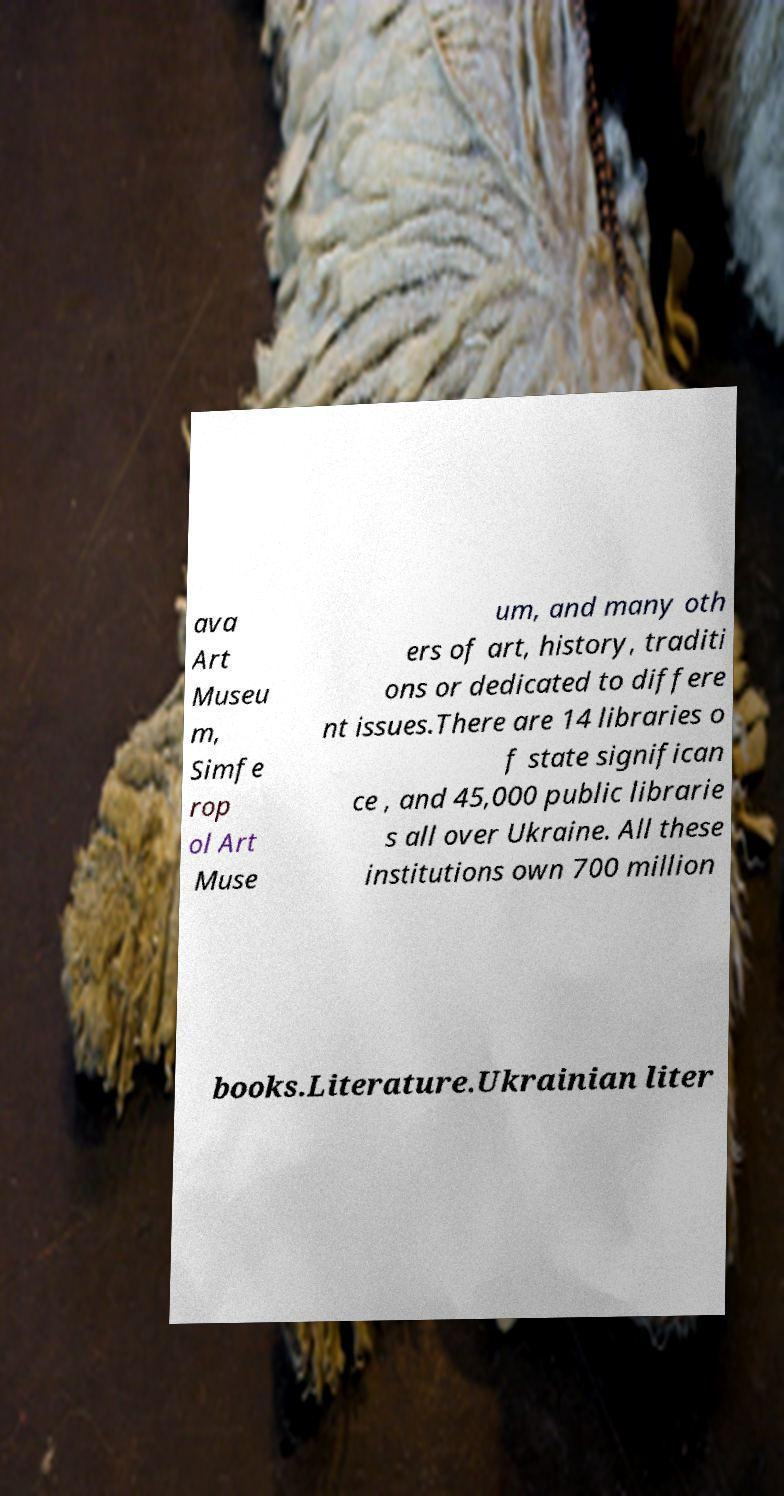Please read and relay the text visible in this image. What does it say? ava Art Museu m, Simfe rop ol Art Muse um, and many oth ers of art, history, traditi ons or dedicated to differe nt issues.There are 14 libraries o f state significan ce , and 45,000 public librarie s all over Ukraine. All these institutions own 700 million books.Literature.Ukrainian liter 